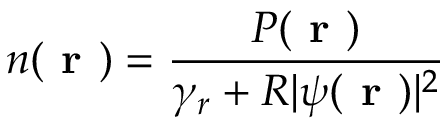<formula> <loc_0><loc_0><loc_500><loc_500>n ( r ) = \frac { P ( r ) } { \gamma _ { r } + R | \psi ( r ) | ^ { 2 } }</formula> 